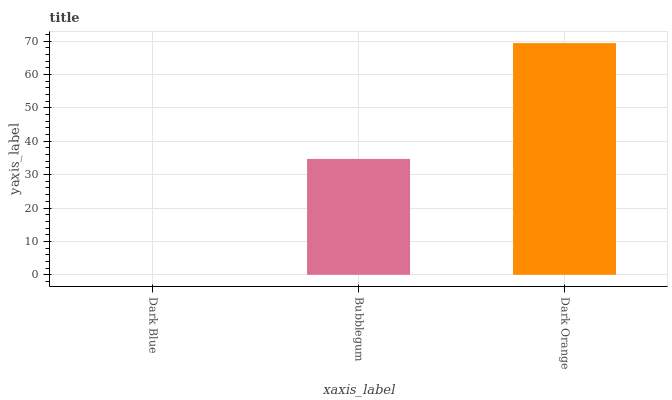Is Dark Blue the minimum?
Answer yes or no. Yes. Is Dark Orange the maximum?
Answer yes or no. Yes. Is Bubblegum the minimum?
Answer yes or no. No. Is Bubblegum the maximum?
Answer yes or no. No. Is Bubblegum greater than Dark Blue?
Answer yes or no. Yes. Is Dark Blue less than Bubblegum?
Answer yes or no. Yes. Is Dark Blue greater than Bubblegum?
Answer yes or no. No. Is Bubblegum less than Dark Blue?
Answer yes or no. No. Is Bubblegum the high median?
Answer yes or no. Yes. Is Bubblegum the low median?
Answer yes or no. Yes. Is Dark Blue the high median?
Answer yes or no. No. Is Dark Blue the low median?
Answer yes or no. No. 